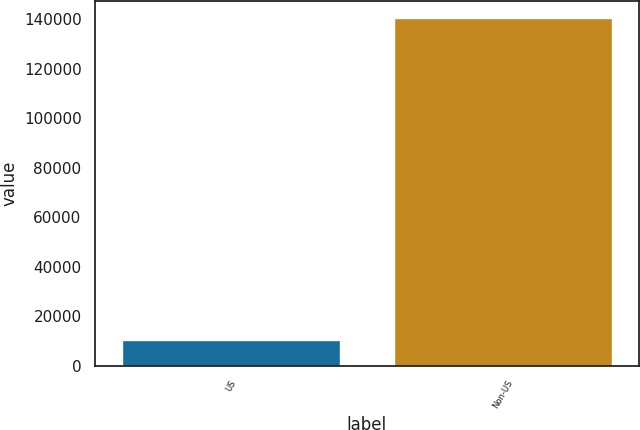Convert chart. <chart><loc_0><loc_0><loc_500><loc_500><bar_chart><fcel>US<fcel>Non-US<nl><fcel>10295<fcel>140441<nl></chart> 